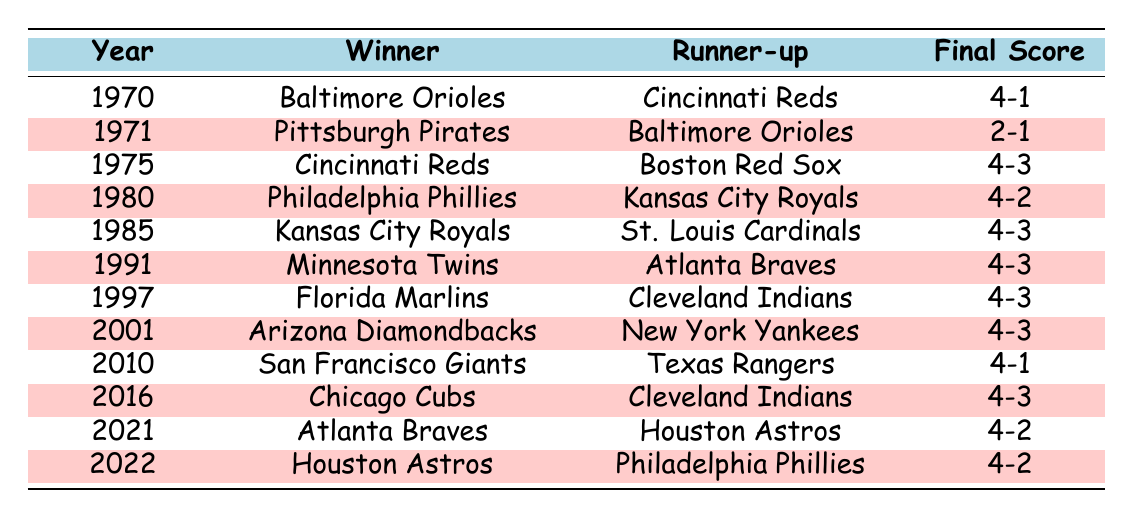What team won the World Series in 1997? The table shows that the winner in 1997 was the Florida Marlins.
Answer: Florida Marlins How many games did the Chicago Cubs win in the 2016 World Series? The final game score for the 2016 World Series shows a 4-3 result, indicating the Cubs won 4 games.
Answer: 4 Did the Baltimore Orioles ever win the World Series from 1970 to 2022? The table indicates that the Baltimore Orioles won the World Series in 1970 but lost in 1971. Thus, they won once during this period.
Answer: Yes What was the final game score in the 1985 World Series? The 1985 World Series final game score is listed as 4-3.
Answer: 4-3 Which teams faced each other in the World Series in 2021? The table states that the Atlanta Braves and Houston Astros faced each other in the 2021 World Series.
Answer: Atlanta Braves and Houston Astros How many times did the World Series go to a Game 7 from 1970 to 2022? The table shows that the World Series went to Game 7 in the years 1975, 1985, 1991, 1997, 2001, 2016; thus, there were 6 occurrences of a Game 7.
Answer: 6 Which team had the lowest number of wins in a World Series that went to at least Game 6? The table indicates that the Pittsburgh Pirates won the 1971 World Series with a score of 2-1, which is the lowest win total in a 7-game series since it stopped at Game 6.
Answer: Pittsburgh Pirates In which years did the final game score end with a winning margin of only one game? From the table, the years that had a final game score of 4-3 (one game margin) are 1975, 1985, 1991, 1997, 2001, and 2016. This reflects a tight competition in those series.
Answer: 1975, 1985, 1991, 1997, 2001, 2016 